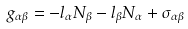Convert formula to latex. <formula><loc_0><loc_0><loc_500><loc_500>g _ { \alpha \beta } = - l _ { \alpha } N _ { \beta } - l _ { \beta } N _ { \alpha } + \sigma _ { \alpha \beta }</formula> 